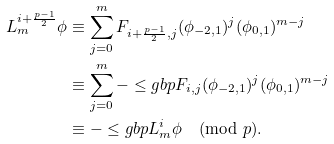Convert formula to latex. <formula><loc_0><loc_0><loc_500><loc_500>L _ { m } ^ { i + \frac { p - 1 } { 2 } } \phi & \equiv \sum _ { j = 0 } ^ { m } F _ { i + \frac { p - 1 } { 2 } , j } ( \phi _ { - 2 , 1 } ) ^ { j } ( \phi _ { 0 , 1 } ) ^ { m - j } \\ & \equiv \sum _ { j = 0 } ^ { m } - \leq g { b } { p } F _ { i , j } ( \phi _ { - 2 , 1 } ) ^ { j } ( \phi _ { 0 , 1 } ) ^ { m - j } \\ & \equiv - \leq g { b } { p } L _ { m } ^ { i } \phi \pmod { p } .</formula> 